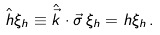<formula> <loc_0><loc_0><loc_500><loc_500>\hat { h } \xi _ { h } \equiv \hat { \vec { k } } \cdot \vec { \sigma } \, \xi _ { h } = h \xi _ { h } \, .</formula> 